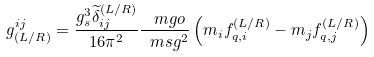Convert formula to latex. <formula><loc_0><loc_0><loc_500><loc_500>g ^ { i j } _ { ( L / R ) } = \frac { g _ { s } ^ { 3 } \widetilde { \delta } ^ { ( L / R ) } _ { i j } } { 1 6 \pi ^ { 2 } } \frac { \ m g o } { \ m s g ^ { 2 } } \left ( m _ { i } f ^ { ( L / R ) } _ { q , i } - m _ { j } f ^ { ( L / R ) } _ { q , j } \right )</formula> 